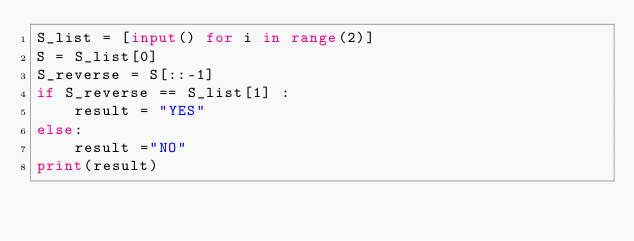<code> <loc_0><loc_0><loc_500><loc_500><_Python_>S_list = [input() for i in range(2)]
S = S_list[0]
S_reverse = S[::-1]
if S_reverse == S_list[1] :
    result = "YES"
else:
    result ="NO"
print(result)</code> 